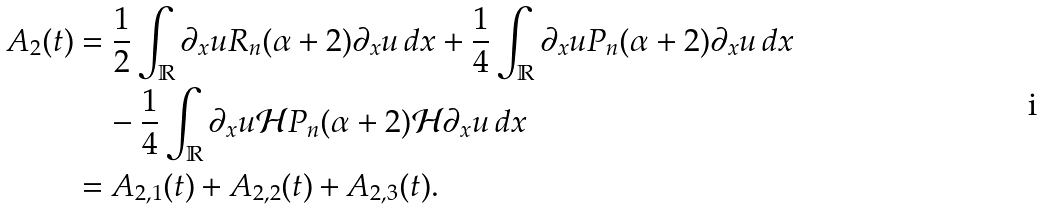<formula> <loc_0><loc_0><loc_500><loc_500>A _ { 2 } ( t ) & = \frac { 1 } { 2 } \int _ { \mathbb { R } } \partial _ { x } u R _ { n } ( \alpha + 2 ) \partial _ { x } u \, d x + \frac { 1 } { 4 } \int _ { \mathbb { R } } \partial _ { x } u P _ { n } ( \alpha + 2 ) \partial _ { x } u \, d x \\ & \quad - \frac { 1 } { 4 } \int _ { \mathbb { R } } \partial _ { x } u \mathcal { H } P _ { n } ( \alpha + 2 ) \mathcal { H } \partial _ { x } u \, d x \\ & = A _ { 2 , 1 } ( t ) + A _ { 2 , 2 } ( t ) + A _ { 2 , 3 } ( t ) .</formula> 